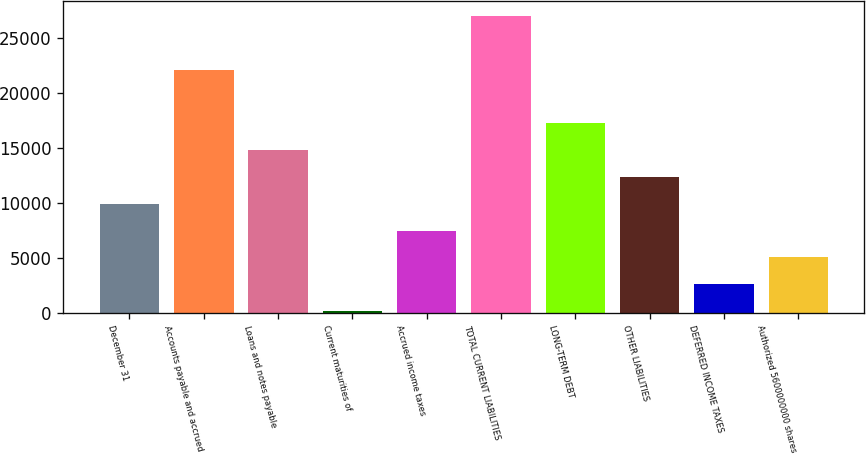Convert chart. <chart><loc_0><loc_0><loc_500><loc_500><bar_chart><fcel>December 31<fcel>Accounts payable and accrued<fcel>Loans and notes payable<fcel>Current maturities of<fcel>Accrued income taxes<fcel>TOTAL CURRENT LIABILITIES<fcel>LONG-TERM DEBT<fcel>OTHER LIABILITIES<fcel>DEFERRED INCOME TAXES<fcel>Authorized 5600000000 shares<nl><fcel>9910.4<fcel>22073.4<fcel>14775.6<fcel>180<fcel>7477.8<fcel>26938.6<fcel>17208.2<fcel>12343<fcel>2612.6<fcel>5045.2<nl></chart> 